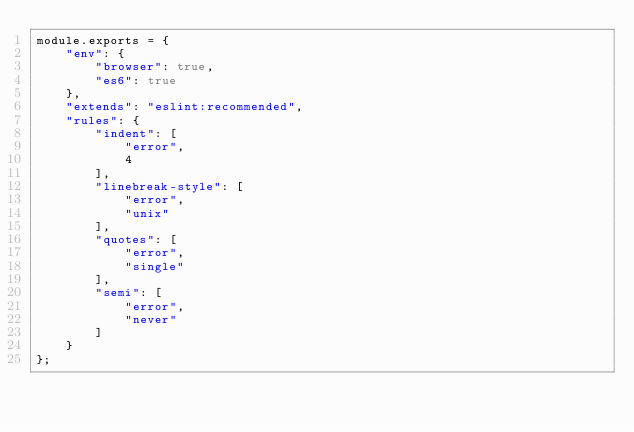Convert code to text. <code><loc_0><loc_0><loc_500><loc_500><_JavaScript_>module.exports = {
    "env": {
        "browser": true,
        "es6": true
    },
    "extends": "eslint:recommended",
    "rules": {
        "indent": [
            "error",
            4
        ],
        "linebreak-style": [
            "error",
            "unix"
        ],
        "quotes": [
            "error",
            "single"
        ],
        "semi": [
            "error",
            "never"
        ]
    }
};</code> 